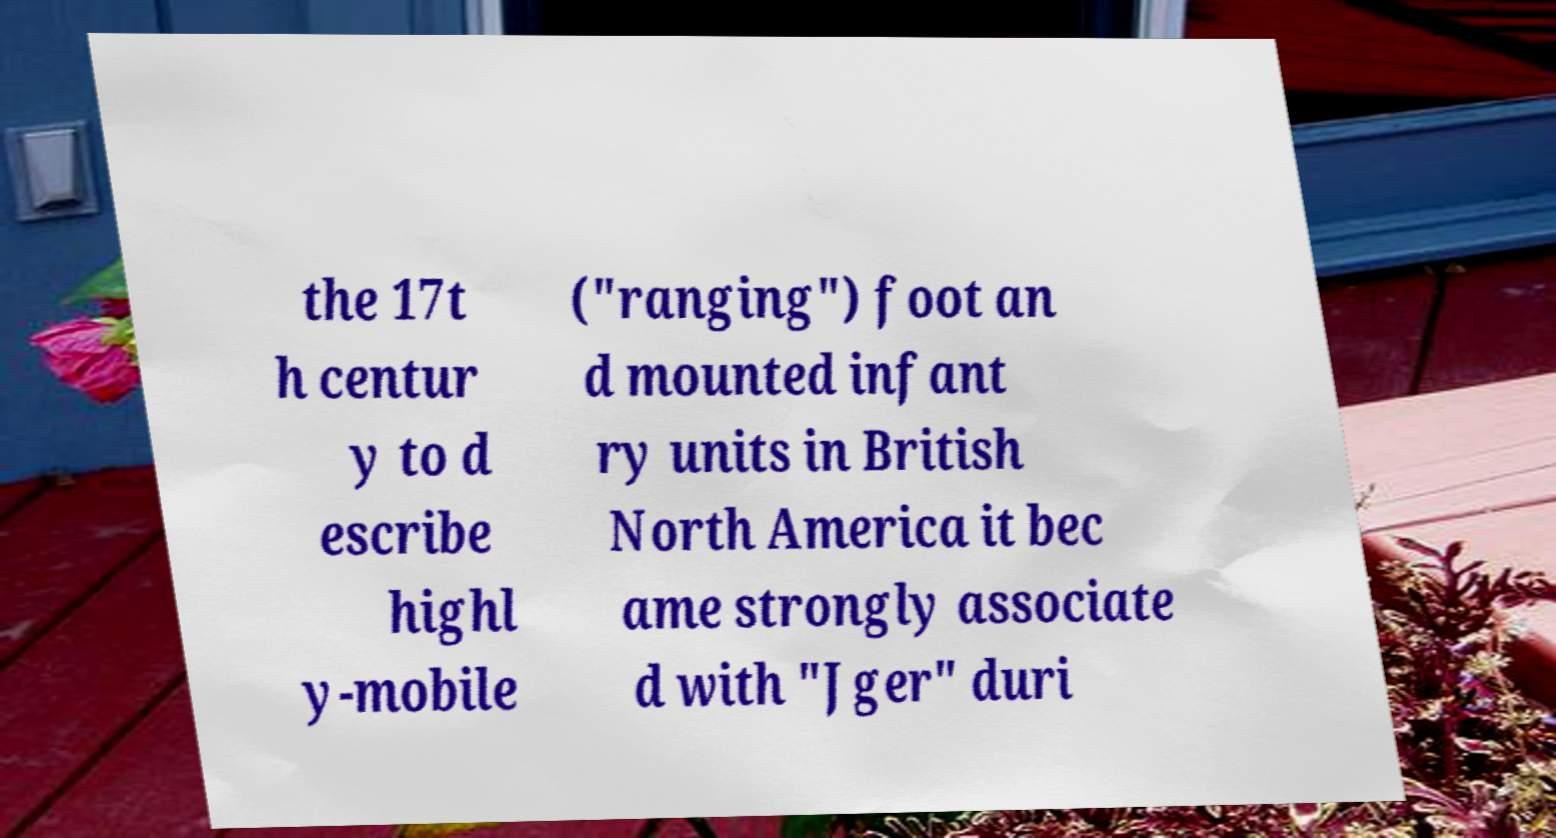Please read and relay the text visible in this image. What does it say? the 17t h centur y to d escribe highl y-mobile ("ranging") foot an d mounted infant ry units in British North America it bec ame strongly associate d with "Jger" duri 